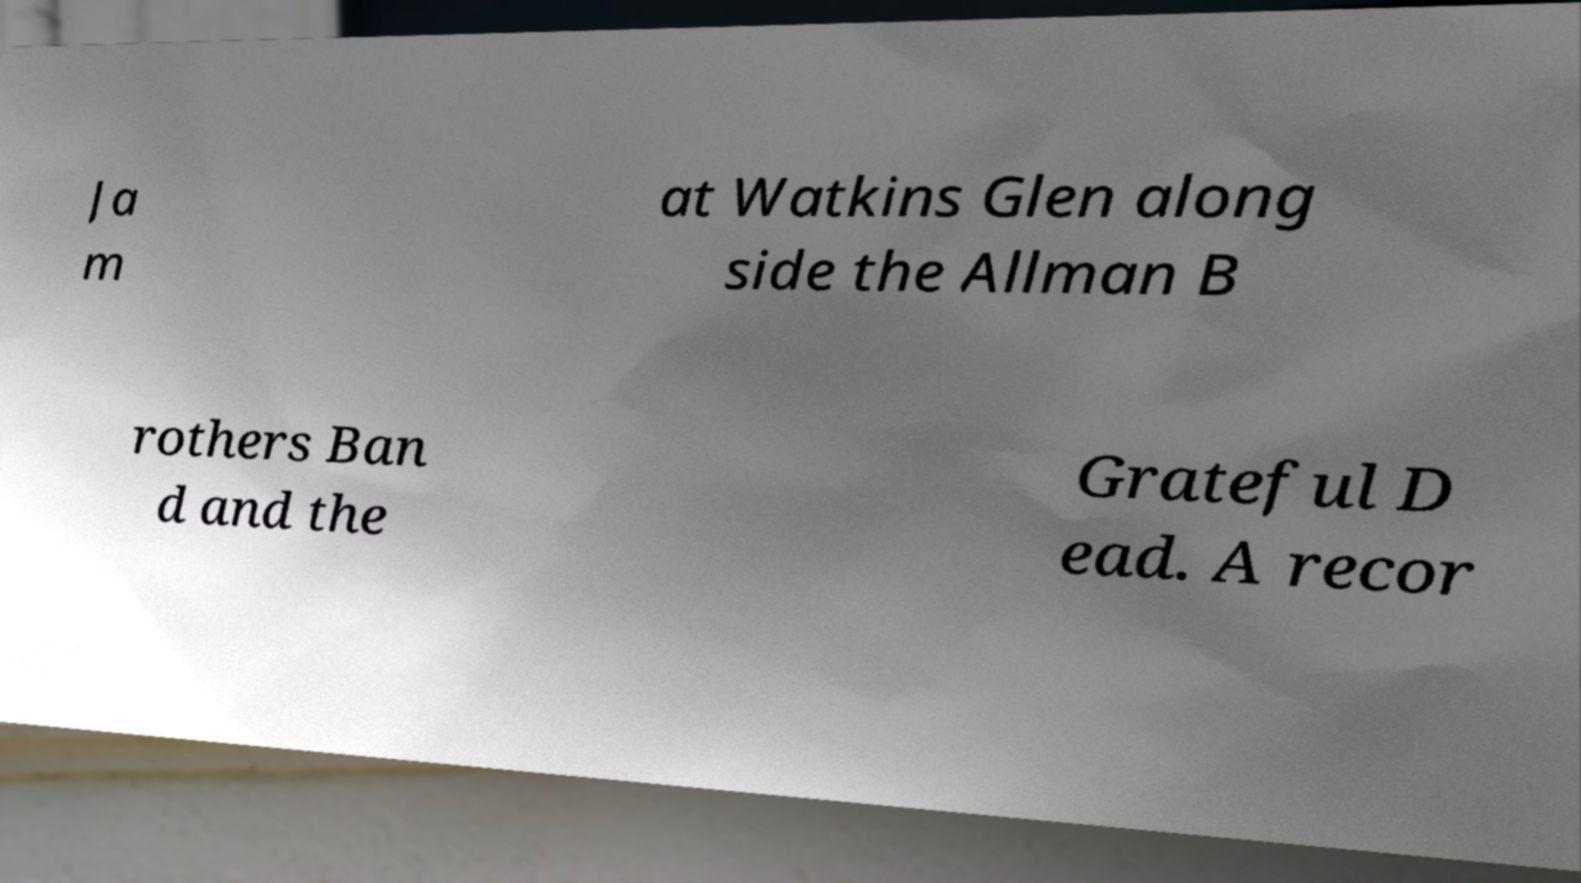Please identify and transcribe the text found in this image. Ja m at Watkins Glen along side the Allman B rothers Ban d and the Grateful D ead. A recor 